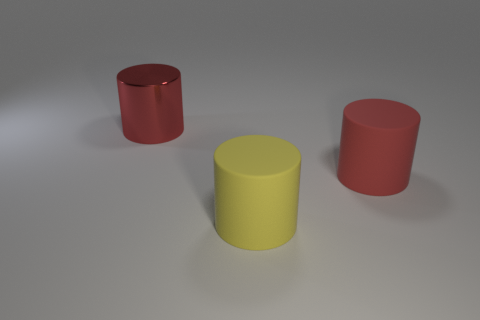What is the size of the object that is behind the yellow rubber cylinder and to the left of the big red rubber object?
Offer a terse response. Large. How many big objects are either yellow objects or red cylinders?
Ensure brevity in your answer.  3. There is a object that is behind the red rubber object; what is its shape?
Provide a short and direct response. Cylinder. How many yellow matte spheres are there?
Give a very brief answer. 0. Are there more rubber cylinders behind the big yellow rubber cylinder than tiny gray shiny balls?
Make the answer very short. Yes. How many things are big yellow rubber objects or cylinders that are in front of the large metallic cylinder?
Provide a succinct answer. 2. Are there more things to the left of the red matte cylinder than big shiny cylinders to the left of the red metal cylinder?
Keep it short and to the point. Yes. What material is the thing left of the big matte object in front of the rubber cylinder behind the yellow cylinder made of?
Give a very brief answer. Metal. The large red thing that is made of the same material as the big yellow object is what shape?
Make the answer very short. Cylinder. There is a red thing that is right of the metallic cylinder; are there any big matte things in front of it?
Make the answer very short. Yes. 